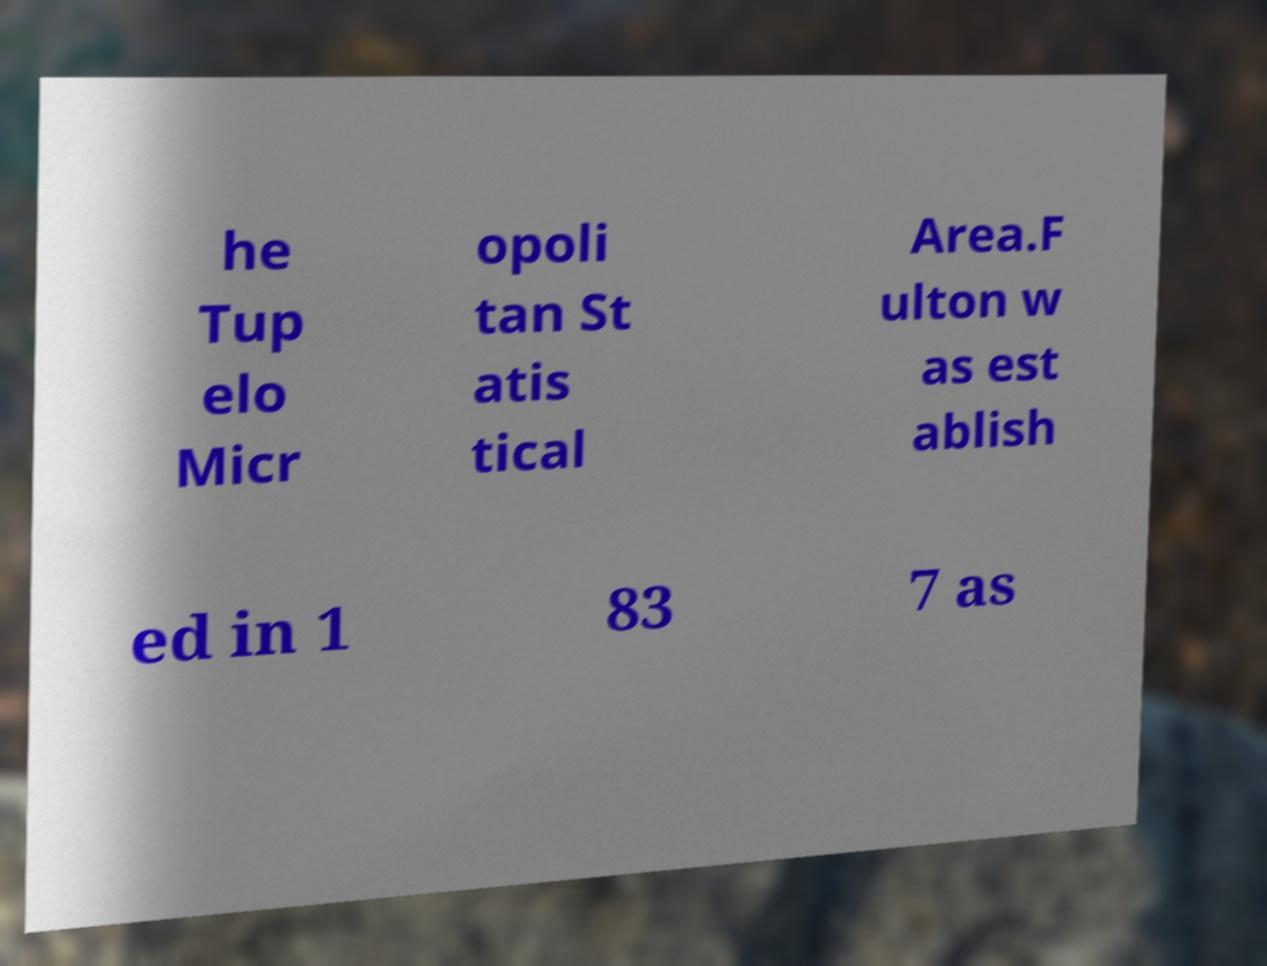What messages or text are displayed in this image? I need them in a readable, typed format. he Tup elo Micr opoli tan St atis tical Area.F ulton w as est ablish ed in 1 83 7 as 